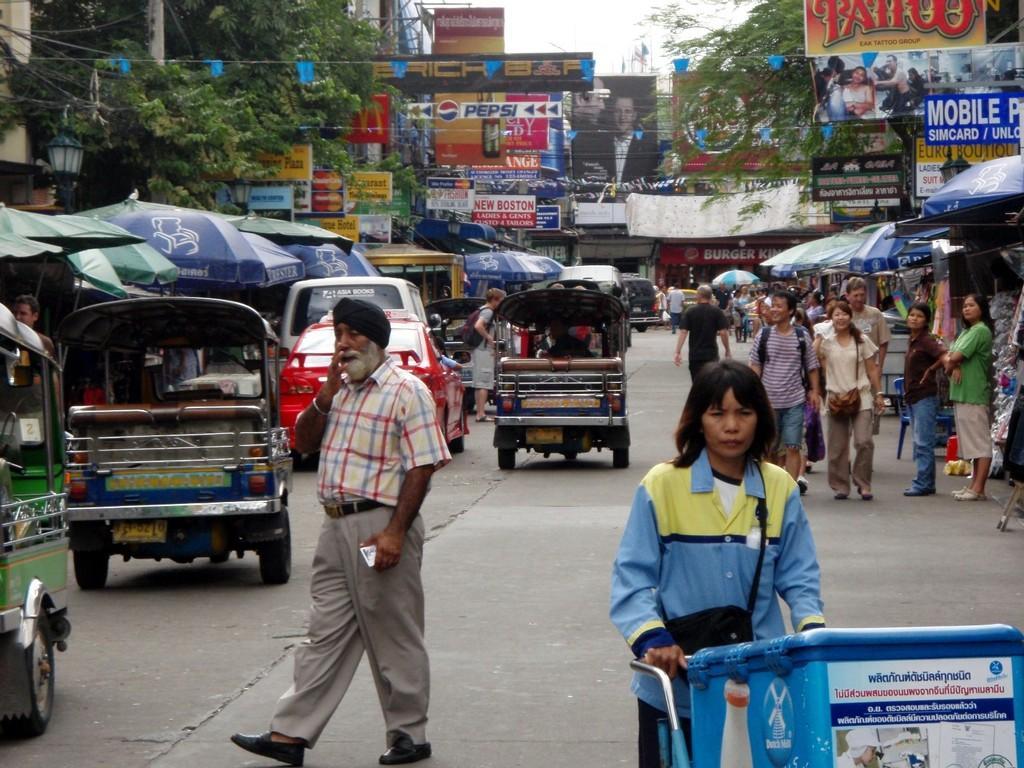Could you give a brief overview of what you see in this image? In this image there are a group of people who are walking on a road, and also there are some vehicles. On the right side and left side there are some stores, trees, hoardings, boards, ropes and flags. And in the background there are some hoardings. At the top of the image there is sky, on the left side there are some umbrellas. On the right side also there are some umbrellas. 